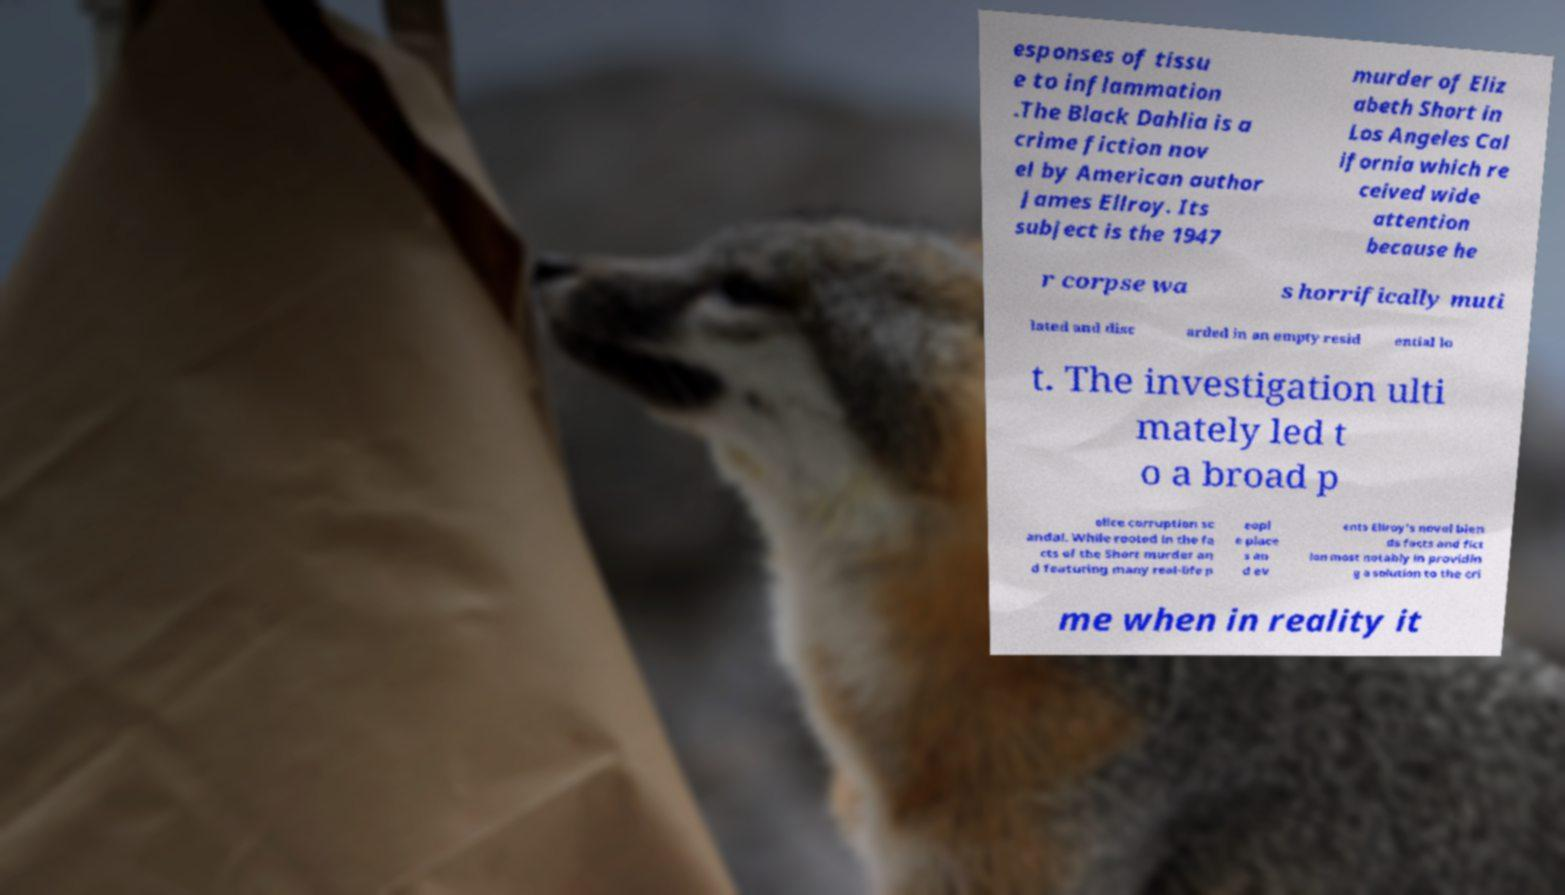Please identify and transcribe the text found in this image. esponses of tissu e to inflammation .The Black Dahlia is a crime fiction nov el by American author James Ellroy. Its subject is the 1947 murder of Eliz abeth Short in Los Angeles Cal ifornia which re ceived wide attention because he r corpse wa s horrifically muti lated and disc arded in an empty resid ential lo t. The investigation ulti mately led t o a broad p olice corruption sc andal. While rooted in the fa cts of the Short murder an d featuring many real-life p eopl e place s an d ev ents Ellroy's novel blen ds facts and fict ion most notably in providin g a solution to the cri me when in reality it 